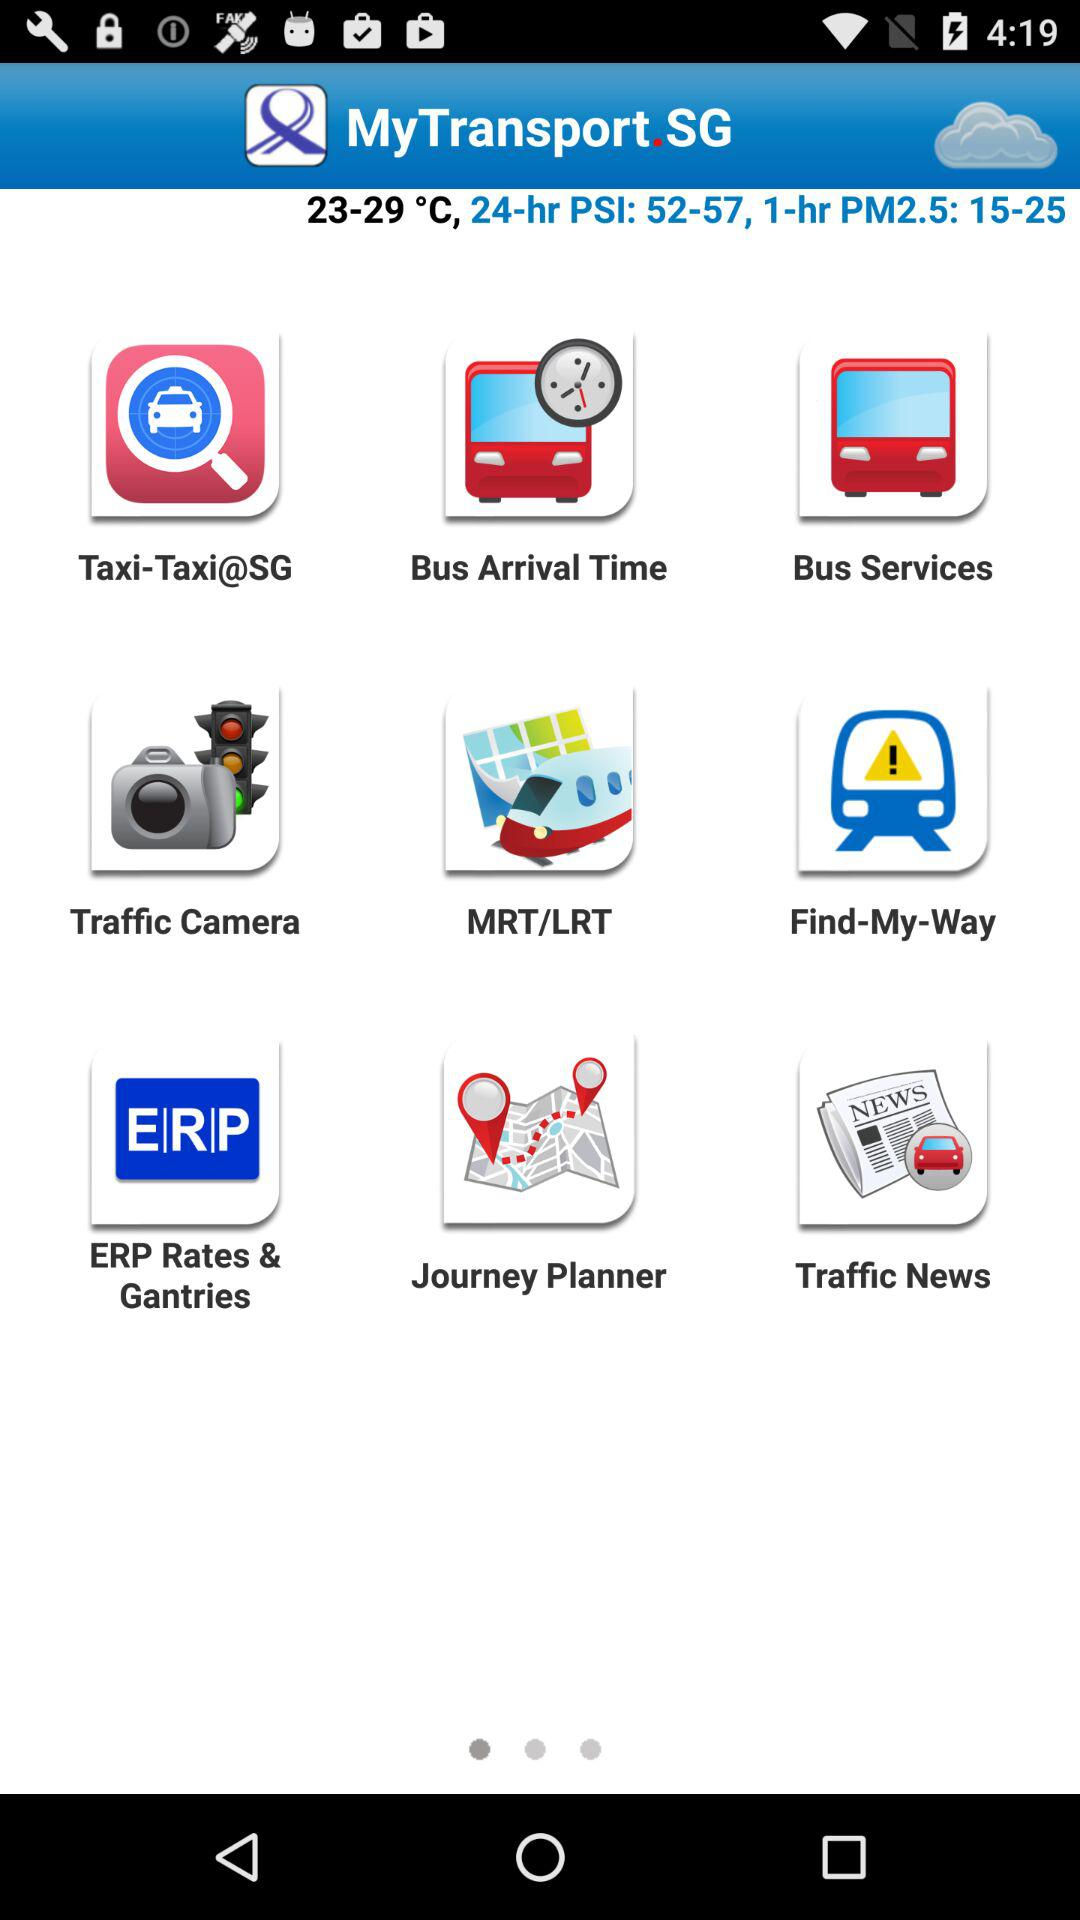What's the temperature? The temperature ranges from 23 °C to 29 °C. 